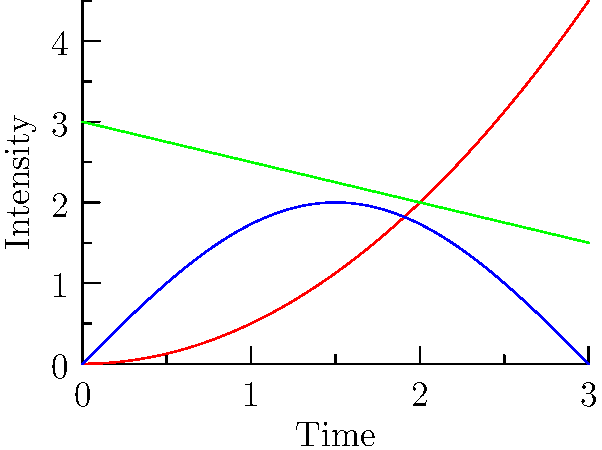In the context of story arc analysis, which line graph best represents the typical structure of a "Hero's Journey" narrative, and why? To answer this question, let's analyze each line graph in relation to the "Hero's Journey" narrative structure:

1. Red line (Rising Action): This parabolic curve shows a steady increase in intensity over time. It represents the hero's gradual progression through challenges and obstacles.

2. Blue line (Climax): This sinusoidal curve depicts fluctuations in intensity, with a clear peak in the middle. It symbolizes the ups and downs of the hero's journey, culminating in a climactic moment.

3. Green line (Resolution): This straight line with a negative slope indicates a gradual decrease in intensity over time. It represents the denouement or resolution phase of the story.

The "Hero's Journey" typically follows a structure where:
1. The hero faces increasing challenges (Rising Action)
2. Encounters a series of trials, leading to a climactic moment (Climax)
3. Returns with newfound knowledge or power, resolving the main conflict (Resolution)

Given this structure, the blue line (Climax) best represents the "Hero's Journey." It shows:
- An initial rise in intensity (Call to Adventure, Crossing the Threshold)
- Fluctuations representing various trials and challenges
- A peak representing the climactic moment (Supreme Ordeal)
- A gradual descent representing the return and resolution

While the other lines capture aspects of the journey, the blue line most comprehensively represents the full arc of the "Hero's Journey" with its characteristic rises, falls, and ultimate climax.
Answer: Blue line (Climax) 